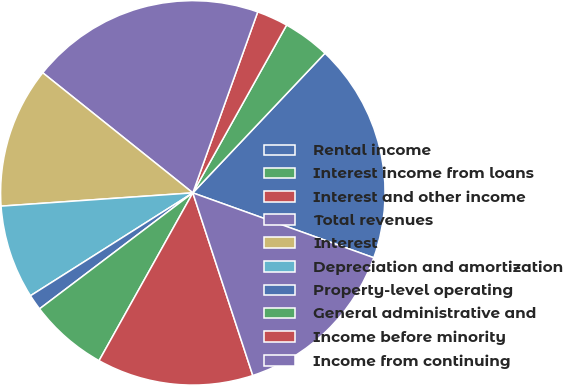Convert chart to OTSL. <chart><loc_0><loc_0><loc_500><loc_500><pie_chart><fcel>Rental income<fcel>Interest income from loans<fcel>Interest and other income<fcel>Total revenues<fcel>Interest<fcel>Depreciation and amortization<fcel>Property-level operating<fcel>General administrative and<fcel>Income before minority<fcel>Income from continuing<nl><fcel>18.42%<fcel>3.95%<fcel>2.63%<fcel>19.74%<fcel>11.84%<fcel>7.89%<fcel>1.32%<fcel>6.58%<fcel>13.16%<fcel>14.47%<nl></chart> 